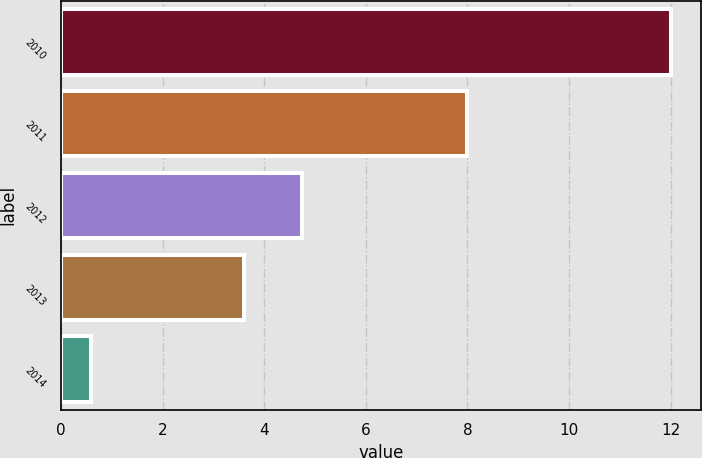Convert chart to OTSL. <chart><loc_0><loc_0><loc_500><loc_500><bar_chart><fcel>2010<fcel>2011<fcel>2012<fcel>2013<fcel>2014<nl><fcel>12<fcel>8<fcel>4.74<fcel>3.6<fcel>0.6<nl></chart> 